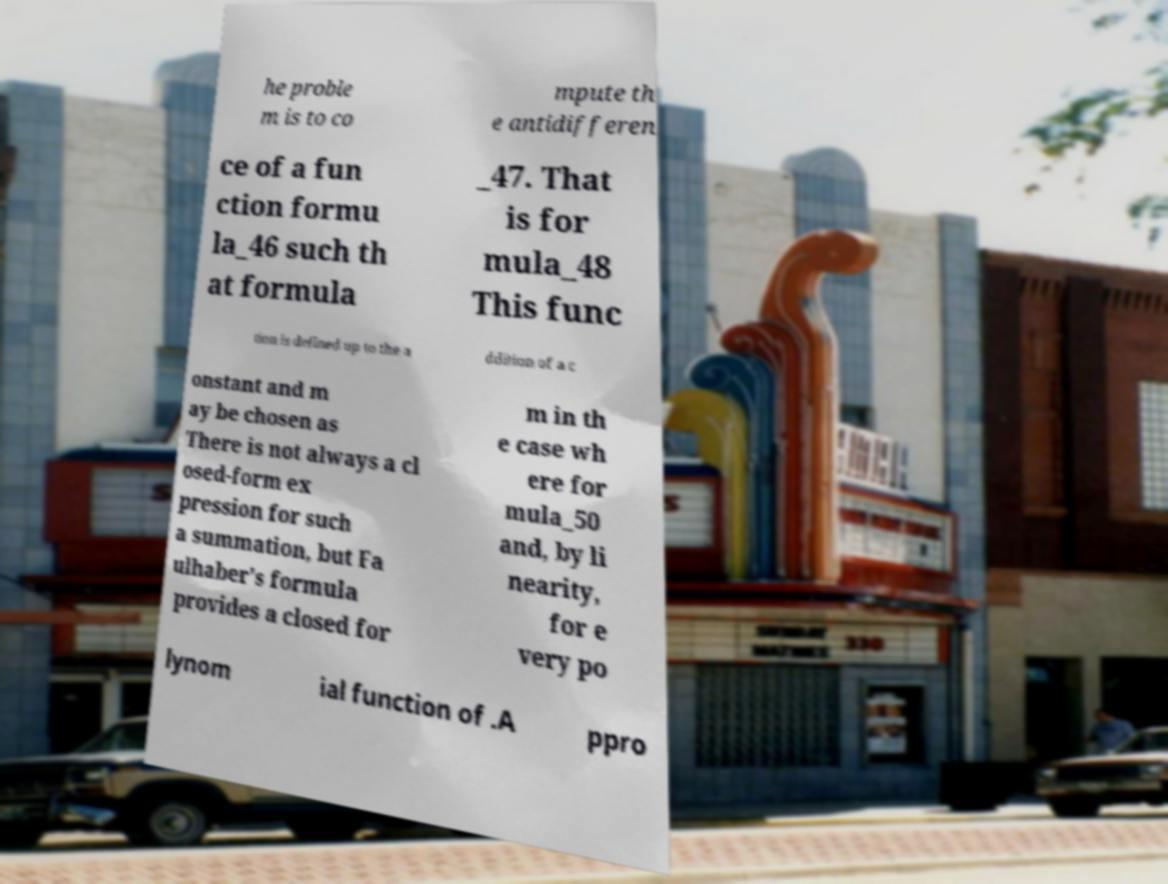Could you assist in decoding the text presented in this image and type it out clearly? he proble m is to co mpute th e antidifferen ce of a fun ction formu la_46 such th at formula _47. That is for mula_48 This func tion is defined up to the a ddition of a c onstant and m ay be chosen as There is not always a cl osed-form ex pression for such a summation, but Fa ulhaber's formula provides a closed for m in th e case wh ere for mula_50 and, by li nearity, for e very po lynom ial function of .A ppro 